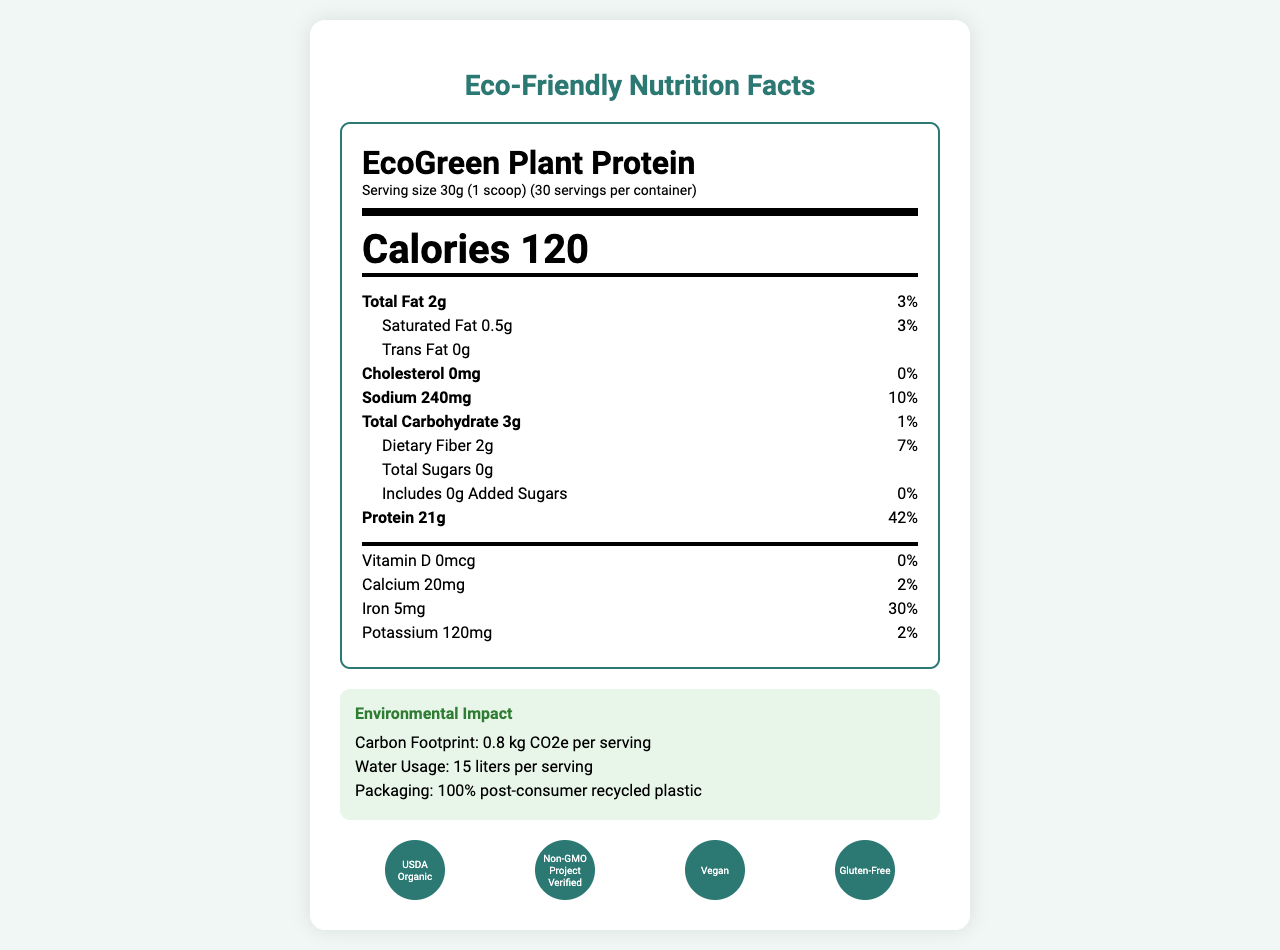what is the serving size? The serving size is stated at the top of the document as "Serving size 30g (1 scoop)".
Answer: 30g (1 scoop) how many servings are in each container? The document mentions there are 30 servings per container right next to the serving size.
Answer: 30 how many calories are in one serving of EcoGreen Plant Protein? The document clearly lists the calorie content as 120 calories per serving, highlighted prominently in large font.
Answer: 120 what is the total fat content per serving? The total fat content per serving is shown as "Total Fat 2g" in the nutrient breakdown section.
Answer: 2g what are the ingredients in EcoGreen Plant Protein? The ingredients are listed towards the bottom of the document under the ingredient section.
Answer: Organic pea protein isolate, Organic brown rice protein, Organic hemp protein, Organic chia seed protein, Natural vanilla flavor, Organic stevia leaf extract, Organic guar gum is this product suitable for individuals with soy allergies? The allergen information states that the product is manufactured in a facility that also processes soy, which could pose a risk to individuals with soy allergies.
Answer: No which certification(s) does this product have? A. USDA Organic B. Fair Trade Certified C. Non-GMO Project Verified D. Certified Humane The product has the USDA Organic and Non-GMO Project Verified certifications, as illustrated by the icons and text.
Answer: A, C how much sodium is in one serving? A. 120mg B. 240mg C. 360mg The sodium content per serving is listed as 240mg.
Answer: B does this product contain any cholesterol? The document states that the cholesterol amount is 0mg.
Answer: No is EcoGreen Plant Protein made using renewable energy? The document mentions that the energy source used for production is 100% renewable energy (solar and wind).
Answer: Yes what is the carbon footprint per serving? The environmental impact section lists the carbon footprint as 0.8 kg CO2e per serving.
Answer: 0.8 kg CO2e per serving does this product contain any added sugars? The document states that the amount of added sugars is 0g.
Answer: No summarize the main environmental impact claims of EcoGreen Plant Protein. The environmental impact details provided include the carbon footprint, water usage, and packaging material, which are important aspects to consider for the product's sustainability.
Answer: EcoGreen Plant Protein has a carbon footprint of 0.8 kg CO2e per serving, uses 15 liters of water per serving, and is packaged in 100% post-consumer recycled plastic. how is the production efficiency described for EcoGreen Plant Protein? The production efficiency is outlined in the engineering insights section stating a 98% resource utilization.
Answer: 98% resource utilization what is the percentage daily value of protein per serving? The protein content is 21g per serving, which corresponds to 42% of the daily value.
Answer: 42% what farms source the ingredients of this protein powder? The document mentions that ingredients are sourced from regenerative agriculture farms but does not specify the names or locations of these farms.
Answer: Not enough information 